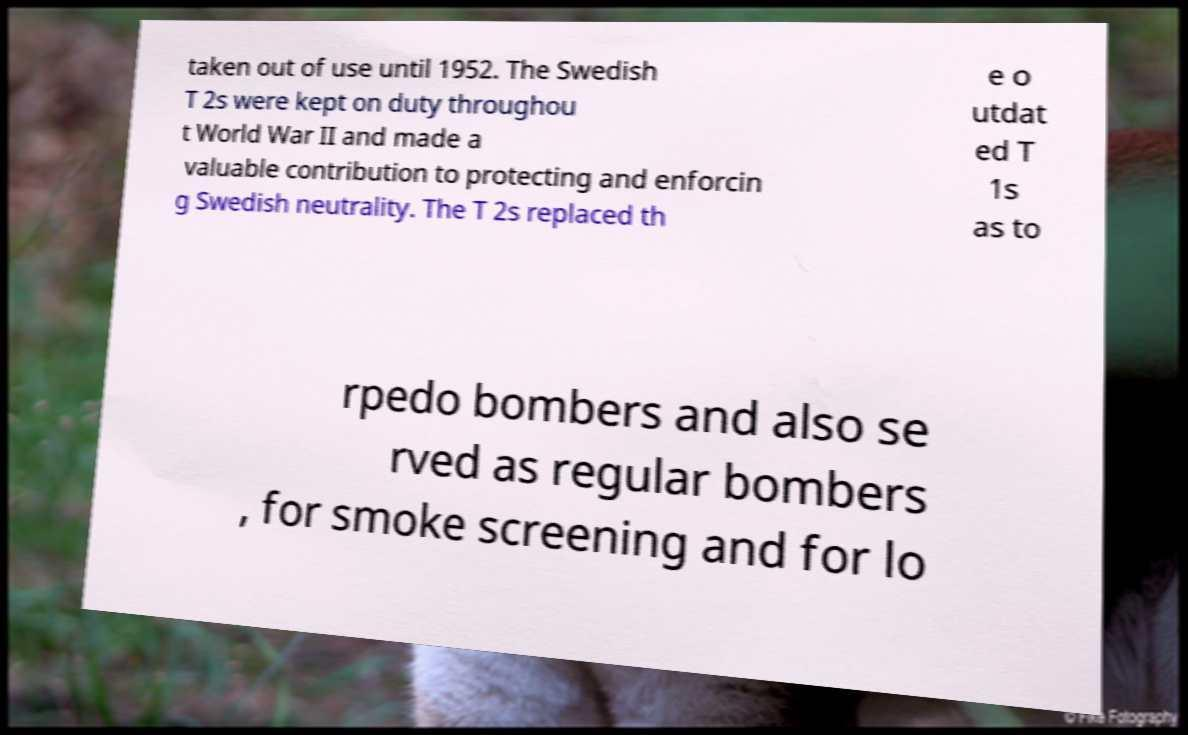Can you accurately transcribe the text from the provided image for me? taken out of use until 1952. The Swedish T 2s were kept on duty throughou t World War II and made a valuable contribution to protecting and enforcin g Swedish neutrality. The T 2s replaced th e o utdat ed T 1s as to rpedo bombers and also se rved as regular bombers , for smoke screening and for lo 